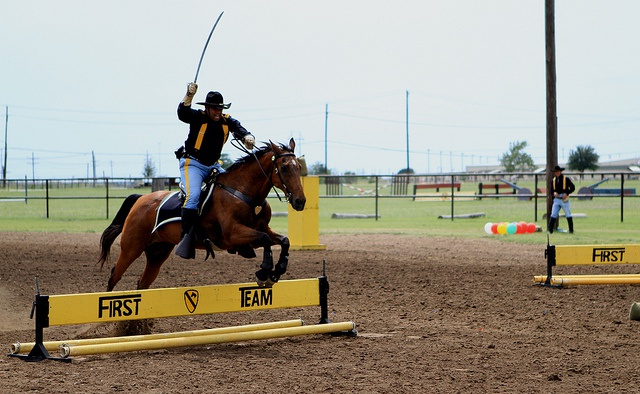Describe the objects in this image and their specific colors. I can see horse in lightgray, black, maroon, and gray tones, people in lightgray, black, darkgray, and gray tones, and people in lightgray, black, and gray tones in this image. 